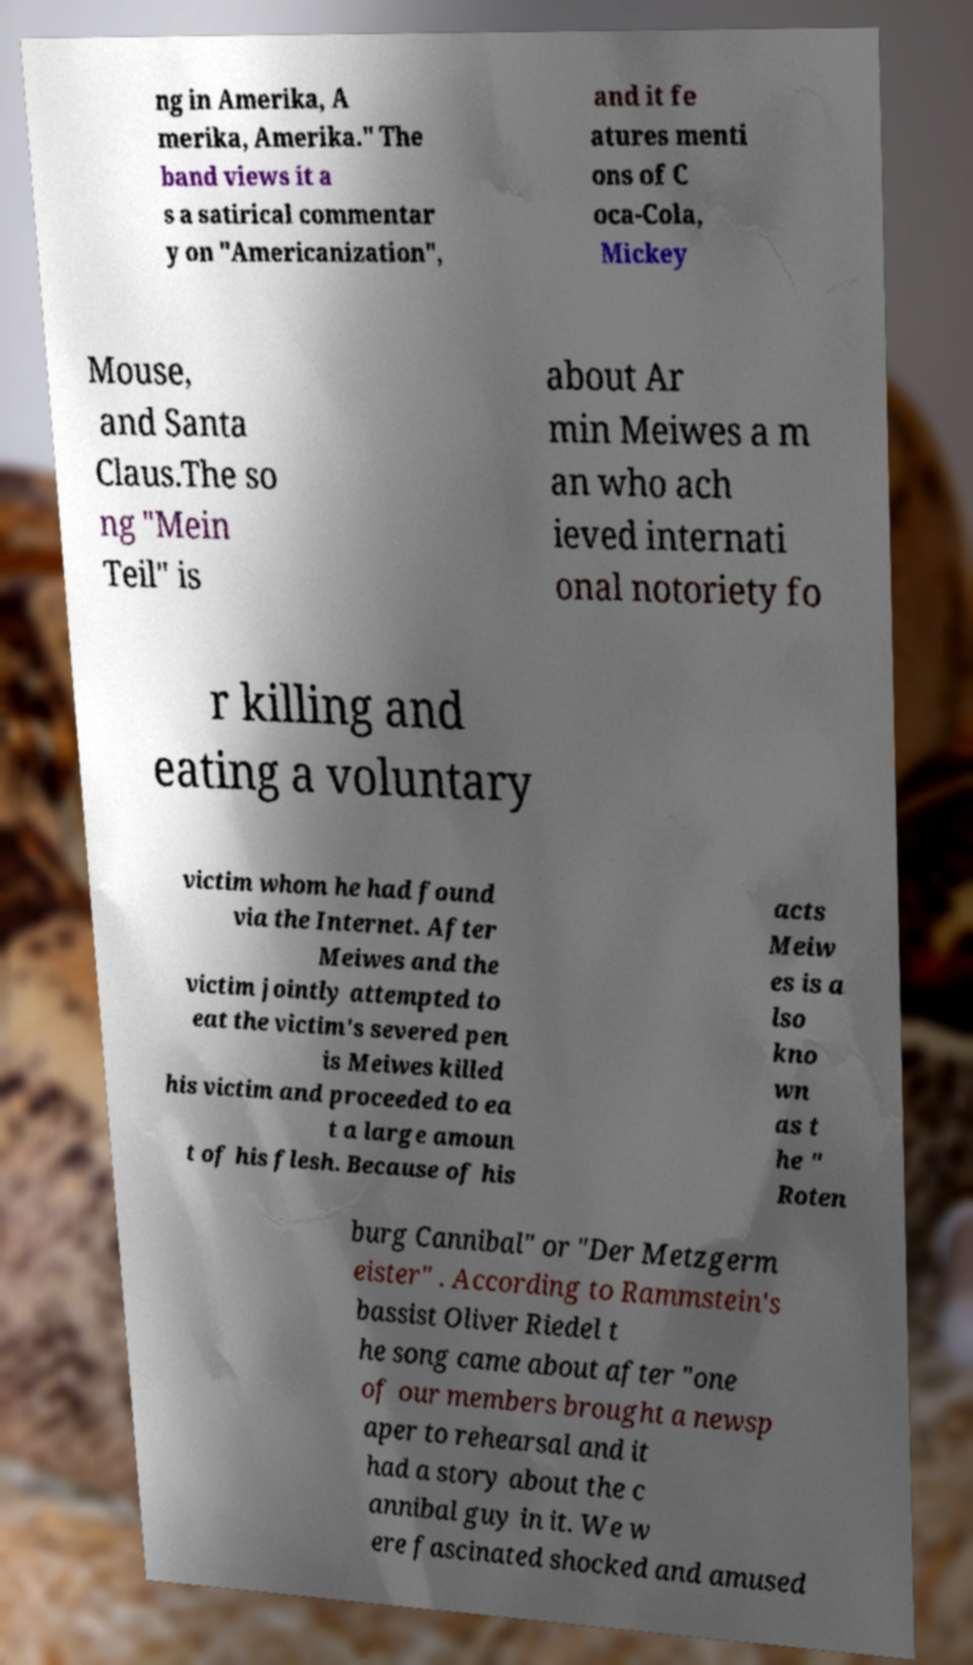Can you read and provide the text displayed in the image?This photo seems to have some interesting text. Can you extract and type it out for me? ng in Amerika, A merika, Amerika." The band views it a s a satirical commentar y on "Americanization", and it fe atures menti ons of C oca-Cola, Mickey Mouse, and Santa Claus.The so ng "Mein Teil" is about Ar min Meiwes a m an who ach ieved internati onal notoriety fo r killing and eating a voluntary victim whom he had found via the Internet. After Meiwes and the victim jointly attempted to eat the victim's severed pen is Meiwes killed his victim and proceeded to ea t a large amoun t of his flesh. Because of his acts Meiw es is a lso kno wn as t he " Roten burg Cannibal" or "Der Metzgerm eister" . According to Rammstein's bassist Oliver Riedel t he song came about after "one of our members brought a newsp aper to rehearsal and it had a story about the c annibal guy in it. We w ere fascinated shocked and amused 